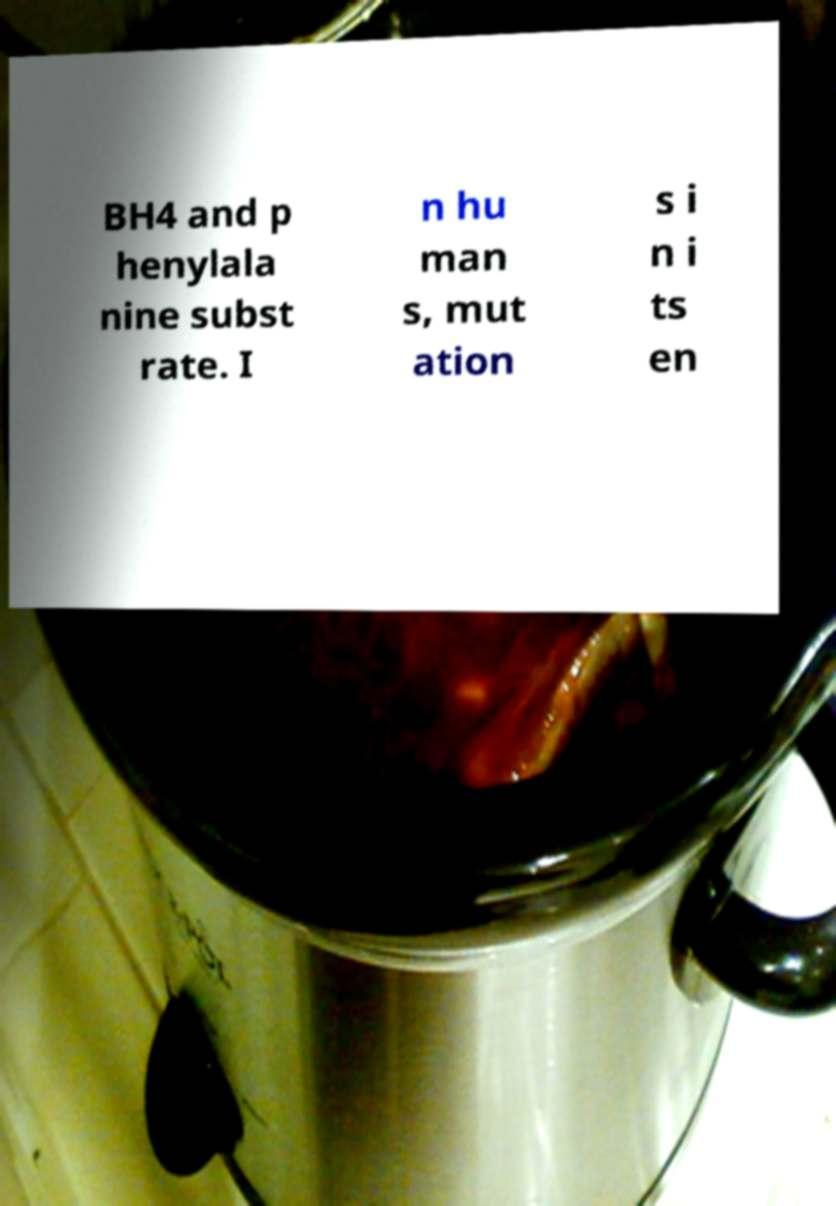Could you extract and type out the text from this image? BH4 and p henylala nine subst rate. I n hu man s, mut ation s i n i ts en 